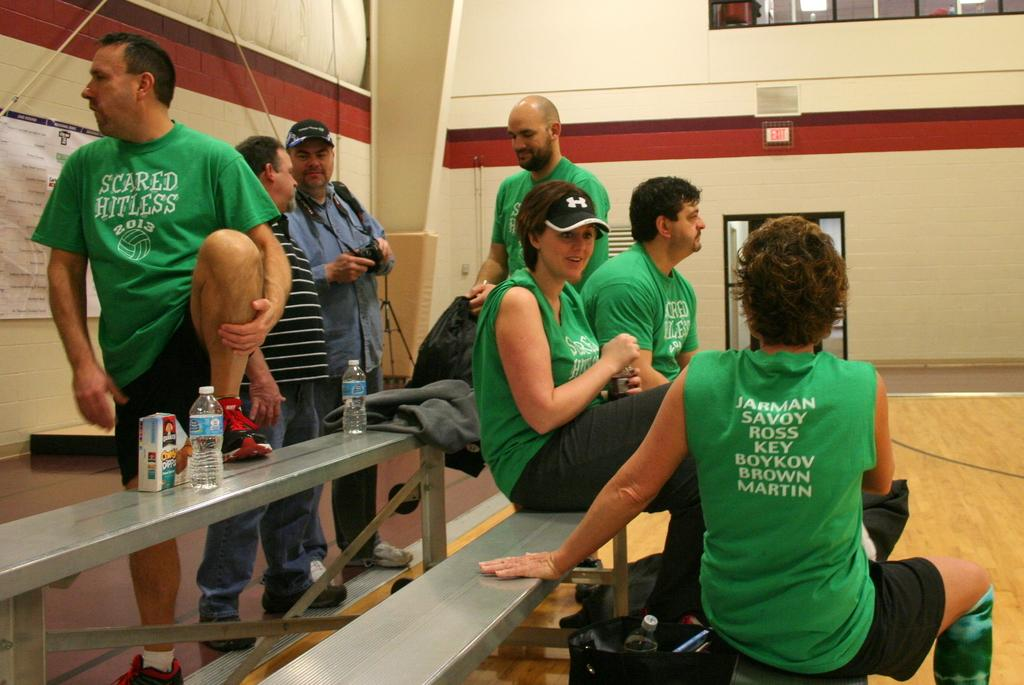What are the people in the image doing? The people in the image are sitting on a bench. Can you describe the objects on the left side of the bench? There are two bottles on the left side of the bench in the image. What is the tendency of the lace in the image? There is no lace present in the image. 